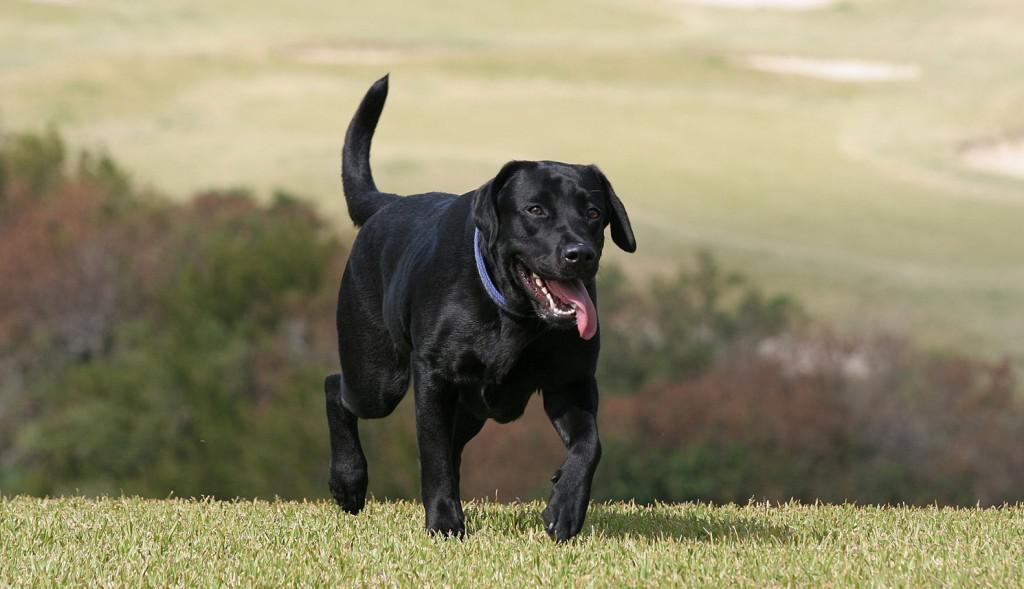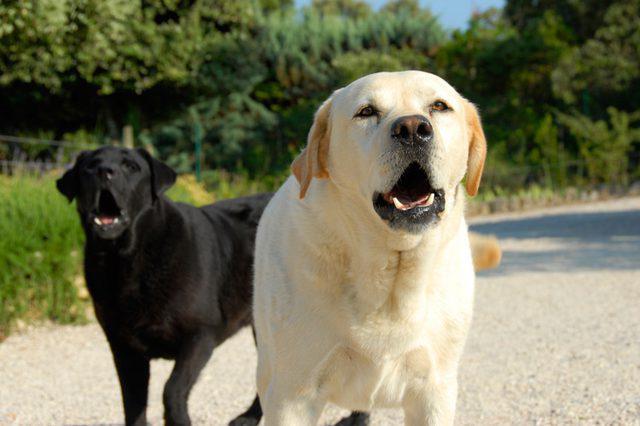The first image is the image on the left, the second image is the image on the right. Assess this claim about the two images: "The right image contains at least three dogs.". Correct or not? Answer yes or no. No. The first image is the image on the left, the second image is the image on the right. Considering the images on both sides, is "One image includes exactly two dogs of different colors, and the other features a single dog." valid? Answer yes or no. Yes. 